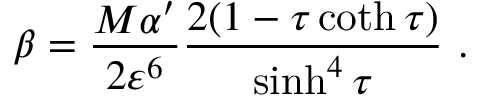Convert formula to latex. <formula><loc_0><loc_0><loc_500><loc_500>\beta = \frac { M \alpha ^ { \prime } } { 2 \varepsilon ^ { 6 } } \frac { 2 ( 1 - \tau \coth \tau ) } { \sinh ^ { 4 } \tau } \ .</formula> 